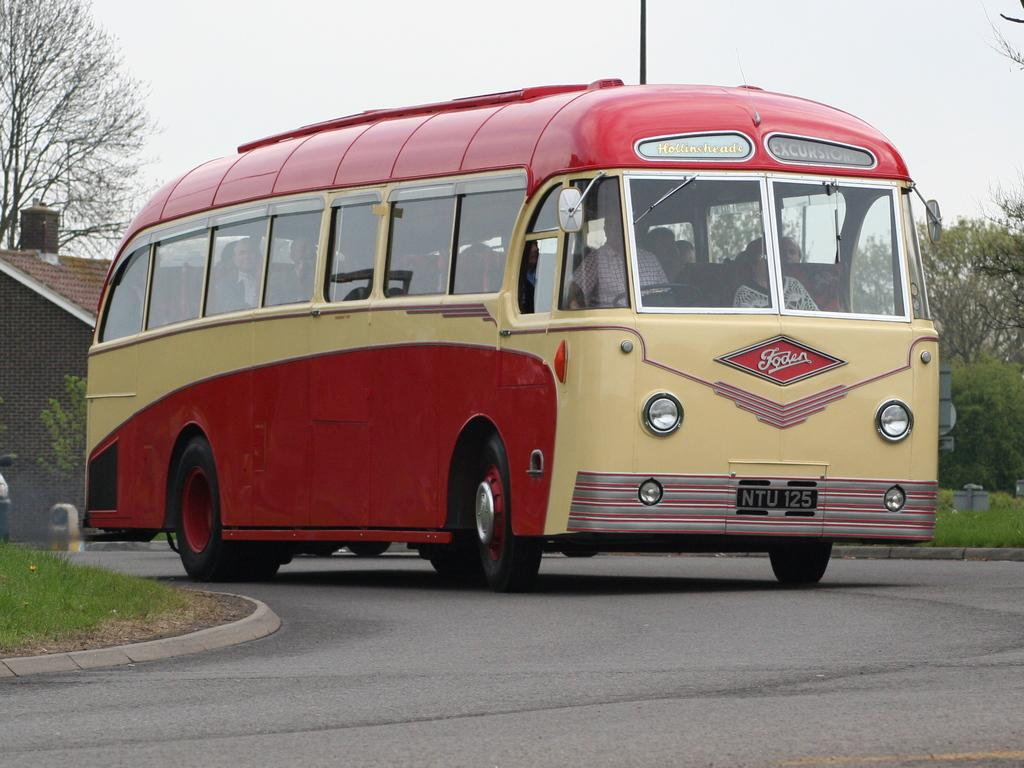What is on the road in the image? There is a vehicle on the road in the image. Who is inside the vehicle? There are people sitting in the vehicle. What are the people wearing? The people are wearing clothes. What type of natural environment can be seen in the image? There is grass visible in the image, as well as trees. What type of structure is present in the image? There is a house in the image. What else can be seen in the image besides the house and trees? There is a pole in the image. What is visible above the ground in the image? The sky is visible in the image. How many girls are sitting on the frog in the image? There is no frog or girls present in the image. What type of jewel is hanging from the pole in the image? There is no jewel hanging from the pole in the image. 